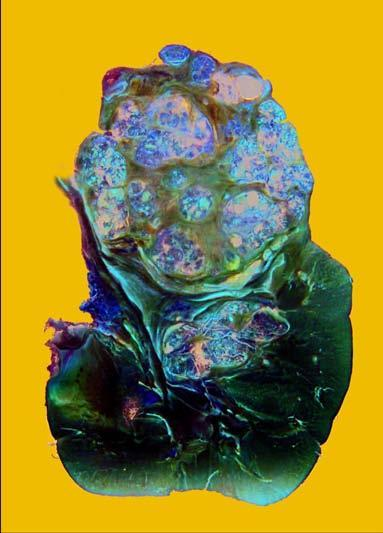does viral rna genome as well as reverse transcriptase show a large and tan mass while rest of the kidney has reniform contour?
Answer the question using a single word or phrase. No 